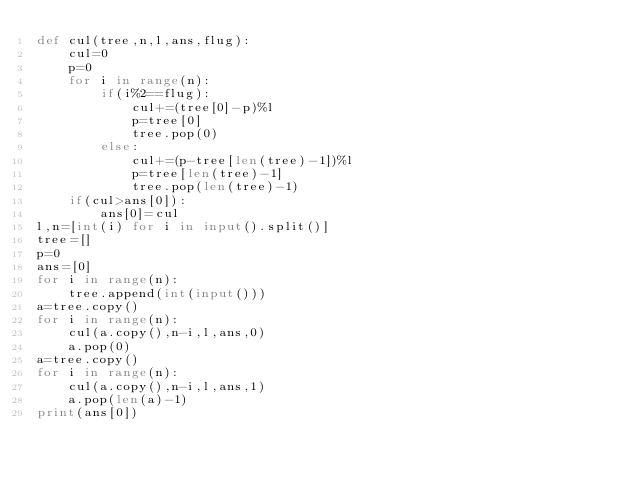Convert code to text. <code><loc_0><loc_0><loc_500><loc_500><_Python_>def cul(tree,n,l,ans,flug):
    cul=0
    p=0
    for i in range(n):
        if(i%2==flug):
            cul+=(tree[0]-p)%l
            p=tree[0]
            tree.pop(0)
        else:
            cul+=(p-tree[len(tree)-1])%l
            p=tree[len(tree)-1]
            tree.pop(len(tree)-1)
    if(cul>ans[0]):
        ans[0]=cul
l,n=[int(i) for i in input().split()]
tree=[]
p=0
ans=[0]
for i in range(n):
    tree.append(int(input()))
a=tree.copy()
for i in range(n):
    cul(a.copy(),n-i,l,ans,0)
    a.pop(0)
a=tree.copy()
for i in range(n):
    cul(a.copy(),n-i,l,ans,1)
    a.pop(len(a)-1)
print(ans[0])</code> 